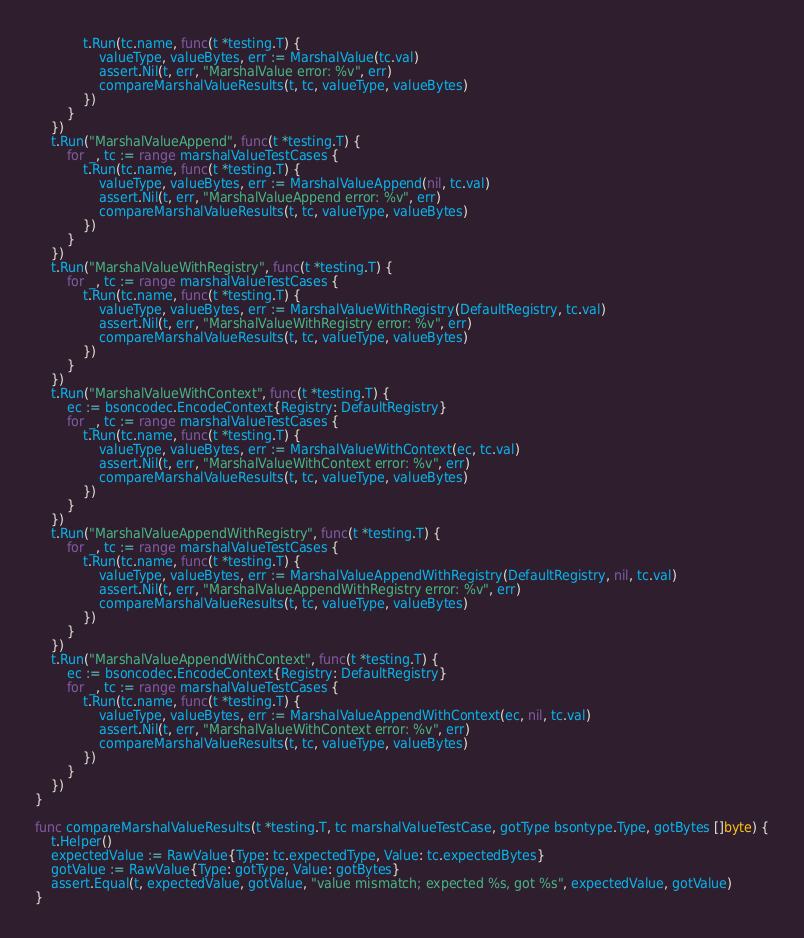Convert code to text. <code><loc_0><loc_0><loc_500><loc_500><_Go_>			t.Run(tc.name, func(t *testing.T) {
				valueType, valueBytes, err := MarshalValue(tc.val)
				assert.Nil(t, err, "MarshalValue error: %v", err)
				compareMarshalValueResults(t, tc, valueType, valueBytes)
			})
		}
	})
	t.Run("MarshalValueAppend", func(t *testing.T) {
		for _, tc := range marshalValueTestCases {
			t.Run(tc.name, func(t *testing.T) {
				valueType, valueBytes, err := MarshalValueAppend(nil, tc.val)
				assert.Nil(t, err, "MarshalValueAppend error: %v", err)
				compareMarshalValueResults(t, tc, valueType, valueBytes)
			})
		}
	})
	t.Run("MarshalValueWithRegistry", func(t *testing.T) {
		for _, tc := range marshalValueTestCases {
			t.Run(tc.name, func(t *testing.T) {
				valueType, valueBytes, err := MarshalValueWithRegistry(DefaultRegistry, tc.val)
				assert.Nil(t, err, "MarshalValueWithRegistry error: %v", err)
				compareMarshalValueResults(t, tc, valueType, valueBytes)
			})
		}
	})
	t.Run("MarshalValueWithContext", func(t *testing.T) {
		ec := bsoncodec.EncodeContext{Registry: DefaultRegistry}
		for _, tc := range marshalValueTestCases {
			t.Run(tc.name, func(t *testing.T) {
				valueType, valueBytes, err := MarshalValueWithContext(ec, tc.val)
				assert.Nil(t, err, "MarshalValueWithContext error: %v", err)
				compareMarshalValueResults(t, tc, valueType, valueBytes)
			})
		}
	})
	t.Run("MarshalValueAppendWithRegistry", func(t *testing.T) {
		for _, tc := range marshalValueTestCases {
			t.Run(tc.name, func(t *testing.T) {
				valueType, valueBytes, err := MarshalValueAppendWithRegistry(DefaultRegistry, nil, tc.val)
				assert.Nil(t, err, "MarshalValueAppendWithRegistry error: %v", err)
				compareMarshalValueResults(t, tc, valueType, valueBytes)
			})
		}
	})
	t.Run("MarshalValueAppendWithContext", func(t *testing.T) {
		ec := bsoncodec.EncodeContext{Registry: DefaultRegistry}
		for _, tc := range marshalValueTestCases {
			t.Run(tc.name, func(t *testing.T) {
				valueType, valueBytes, err := MarshalValueAppendWithContext(ec, nil, tc.val)
				assert.Nil(t, err, "MarshalValueWithContext error: %v", err)
				compareMarshalValueResults(t, tc, valueType, valueBytes)
			})
		}
	})
}

func compareMarshalValueResults(t *testing.T, tc marshalValueTestCase, gotType bsontype.Type, gotBytes []byte) {
	t.Helper()
	expectedValue := RawValue{Type: tc.expectedType, Value: tc.expectedBytes}
	gotValue := RawValue{Type: gotType, Value: gotBytes}
	assert.Equal(t, expectedValue, gotValue, "value mismatch; expected %s, got %s", expectedValue, gotValue)
}
</code> 